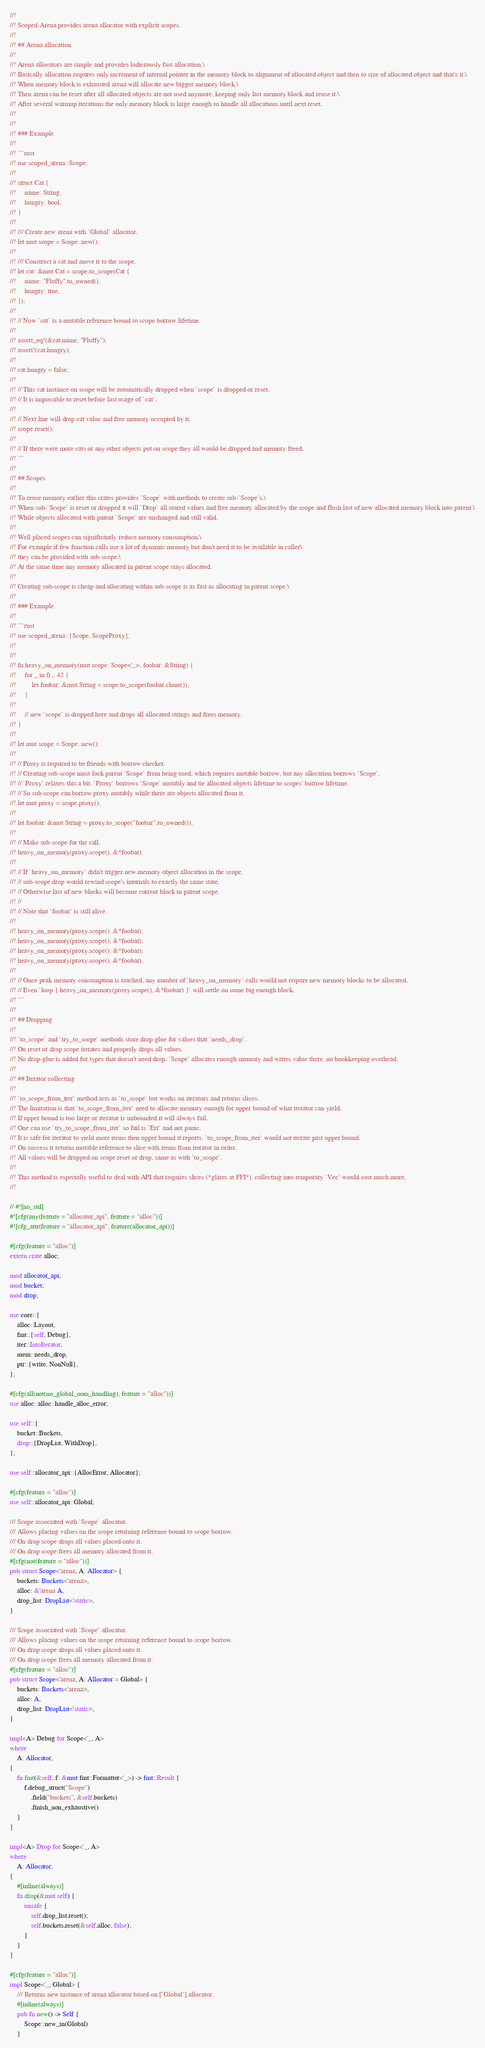<code> <loc_0><loc_0><loc_500><loc_500><_Rust_>//!
//! Scoped-Arena provides arena allocator with explicit scopes.
//!
//! ## Arena allocation
//!
//! Arena allocators are simple and provides ludicrously fast allocation.\
//! Basically allocation requires only increment of internal pointer in the memory block to alignment of allocated object and then to size of allocated object and that's it.\
//! When memory block is exhausted arena will allocate new bigger memory block.\
//! Then arena can be reset after all allocated objects are not used anymore, keeping only last memory block and reuse it.\
//! After several warmup iterations the only memory block is large enough to handle all allocations until next reset.
//!
//!
//! ### Example
//!
//! ```rust
//! use scoped_arena::Scope;
//!
//! struct Cat {
//!     name: String,
//!     hungry: bool,
//! }
//!
//! /// Create new arena with `Global` allocator.
//! let mut scope = Scope::new();
//!
//! /// Construct a cat and move it to the scope.
//! let cat: &mut Cat = scope.to_scope(Cat {
//!     name: "Fluffy".to_owned(),
//!     hungry: true,
//! });
//!
//! // Now `cat` is a mutable reference bound to scope borrow lifetime.
//!
//! assert_eq!(&cat.name, "Fluffy");
//! assert!(cat.hungry);
//!
//! cat.hungry = false;
//!
//! // This cat instance on scope will be automatically dropped when `scope` is dropped or reset.
//! // It is impossible to reset before last usage of `cat`.
//!
//! // Next line will drop cat value and free memory occupied by it.
//! scope.reset();
//!
//! // If there were more cats or any other objects put on scope they all would be dropped and memory freed.
//! ```
//!
//! ## Scopes
//!
//! To reuse memory earlier this crates provides `Scope` with methods to create sub-`Scope`s.\
//! When sub-`Scope` is reset or dropped it will `Drop` all stored values and free memory allocated by the scope and flush last of new allocated memory block into parent.\
//! While objects allocated with parent `Scope` are unchanged and still valid.
//!
//! Well placed scopes can significantly reduce memory consumption.\
//! For example if few function calls use a lot of dynamic memory but don't need it to be available in caller\
//! they can be provided with sub-scope.\
//! At the same time any memory allocated in parent scope stays allocated.
//!
//! Creating sub-scope is cheap and allocating within sub-scope is as fast as allocating in parent scope.\
//!
//! ### Example
//!
//! ```rust
//! use scoped_arena::{Scope, ScopeProxy};
//!
//!
//! fn heavy_on_memory(mut scope: Scope<'_>, foobar: &String) {
//!     for _ in 0 .. 42 {
//!         let foobar: &mut String = scope.to_scope(foobar.clone());
//!     }
//!
//!     // new `scope` is dropped here and drops all allocated strings and frees memory.
//! }
//!
//! let mut scope = Scope::new();
//!
//! // Proxy is required to be friends with borrow checker.
//! // Creating sub-scope must lock parent `Scope` from being used, which requires mutable borrow, but any allocation borrows `Scope`.
//! // `Proxy` relaxes this a bit. `Proxy` borrows `Scope` mutably and tie allocated objects lifetime to scopes' borrow lifetime.
//! // So sub-scope can borrow proxy mutably while there are objects allocated from it.
//! let mut proxy = scope.proxy();
//!
//! let foobar: &mut String = proxy.to_scope("foobar".to_owned());
//!
//! // Make sub-scope for the call.
//! heavy_on_memory(proxy.scope(), &*foobar);
//!
//! // If `heavy_on_memory` didn't trigger new memory object allocation in the scope,
//! // sub-scope drop would rewind scope's internals to exactly the same state.
//! // Otherwise last of new blocks will become current block in parent scope.
//! //
//! // Note that `foobar` is still alive.
//!
//! heavy_on_memory(proxy.scope(), &*foobar);
//! heavy_on_memory(proxy.scope(), &*foobar);
//! heavy_on_memory(proxy.scope(), &*foobar);
//! heavy_on_memory(proxy.scope(), &*foobar);
//!
//! // Once peak memory consumption is reached, any number of `heavy_on_memory` calls would not require new memory blocks to be allocated.
//! // Even `loop { heavy_on_memory(proxy.scope(), &*foobar) }` will settle on some big enough block.
//! ```
//!
//! ## Dropping
//!
//! `to_scope` and `try_to_scope` methods store drop-glue for values that `needs_drop`.
//! On reset or drop scope iterates and properly drops all values.
//! No drop-glue is added for types that doesn't need drop. `Scope` allocates enough memory and writes value there, no bookkeeping overhead.
//!
//! ## Iterator collecting
//!
//! `to_scope_from_iter` method acts as `to_scope` but works on iterators and returns slices.
//! The limitation is that `to_scope_from_iter` need to allocate memory enough for upper bound of what iterator can yield.
//! If upper bound is too large or iterator is unbounded it will always fail.
//! One can use `try_to_scope_from_iter` so fail is `Err` and not panic.
//! It is safe for iterator to yield more items then upper bound it reports, `to_scope_from_iter` would not iterate past upper bound.
//! On success it returns mutable reference to slice with items from iterator in order.
//! All values will be dropped on scope reset or drop, same as with `to_scope`.
//!
//! This method is especially useful to deal with API that requires slices (*glares at FFI*), collecting into temporary `Vec` would cost much more.
//!

// #![no_std]
#![cfg(any(feature = "allocator_api", feature = "alloc"))]
#![cfg_attr(feature = "allocator_api", feature(allocator_api))]

#[cfg(feature = "alloc")]
extern crate alloc;

mod allocator_api;
mod bucket;
mod drop;

use core::{
    alloc::Layout,
    fmt::{self, Debug},
    iter::IntoIterator,
    mem::needs_drop,
    ptr::{write, NonNull},
};

#[cfg(all(not(no_global_oom_handling), feature = "alloc"))]
use alloc::alloc::handle_alloc_error;

use self::{
    bucket::Buckets,
    drop::{DropList, WithDrop},
};

use self::allocator_api::{AllocError, Allocator};

#[cfg(feature = "alloc")]
use self::allocator_api::Global;

/// Scope associated with `Scope` allocator.
/// Allows placing values on the scope returning reference bound to scope borrow.
/// On drop scope drops all values placed onto it.
/// On drop scope frees all memory allocated from it.
#[cfg(not(feature = "alloc"))]
pub struct Scope<'arena, A: Allocator> {
    buckets: Buckets<'arena>,
    alloc: &'arena A,
    drop_list: DropList<'static>,
}

/// Scope associated with `Scope` allocator.
/// Allows placing values on the scope returning reference bound to scope borrow.
/// On drop scope drops all values placed onto it.
/// On drop scope frees all memory allocated from it.
#[cfg(feature = "alloc")]
pub struct Scope<'arena, A: Allocator = Global> {
    buckets: Buckets<'arena>,
    alloc: A,
    drop_list: DropList<'static>,
}

impl<A> Debug for Scope<'_, A>
where
    A: Allocator,
{
    fn fmt(&self, f: &mut fmt::Formatter<'_>) -> fmt::Result {
        f.debug_struct("Scope")
            .field("buckets", &self.buckets)
            .finish_non_exhaustive()
    }
}

impl<A> Drop for Scope<'_, A>
where
    A: Allocator,
{
    #[inline(always)]
    fn drop(&mut self) {
        unsafe {
            self.drop_list.reset();
            self.buckets.reset(&self.alloc, false);
        }
    }
}

#[cfg(feature = "alloc")]
impl Scope<'_, Global> {
    /// Returns new instance of arena allocator based on [`Global`] allocator.
    #[inline(always)]
    pub fn new() -> Self {
        Scope::new_in(Global)
    }
</code> 